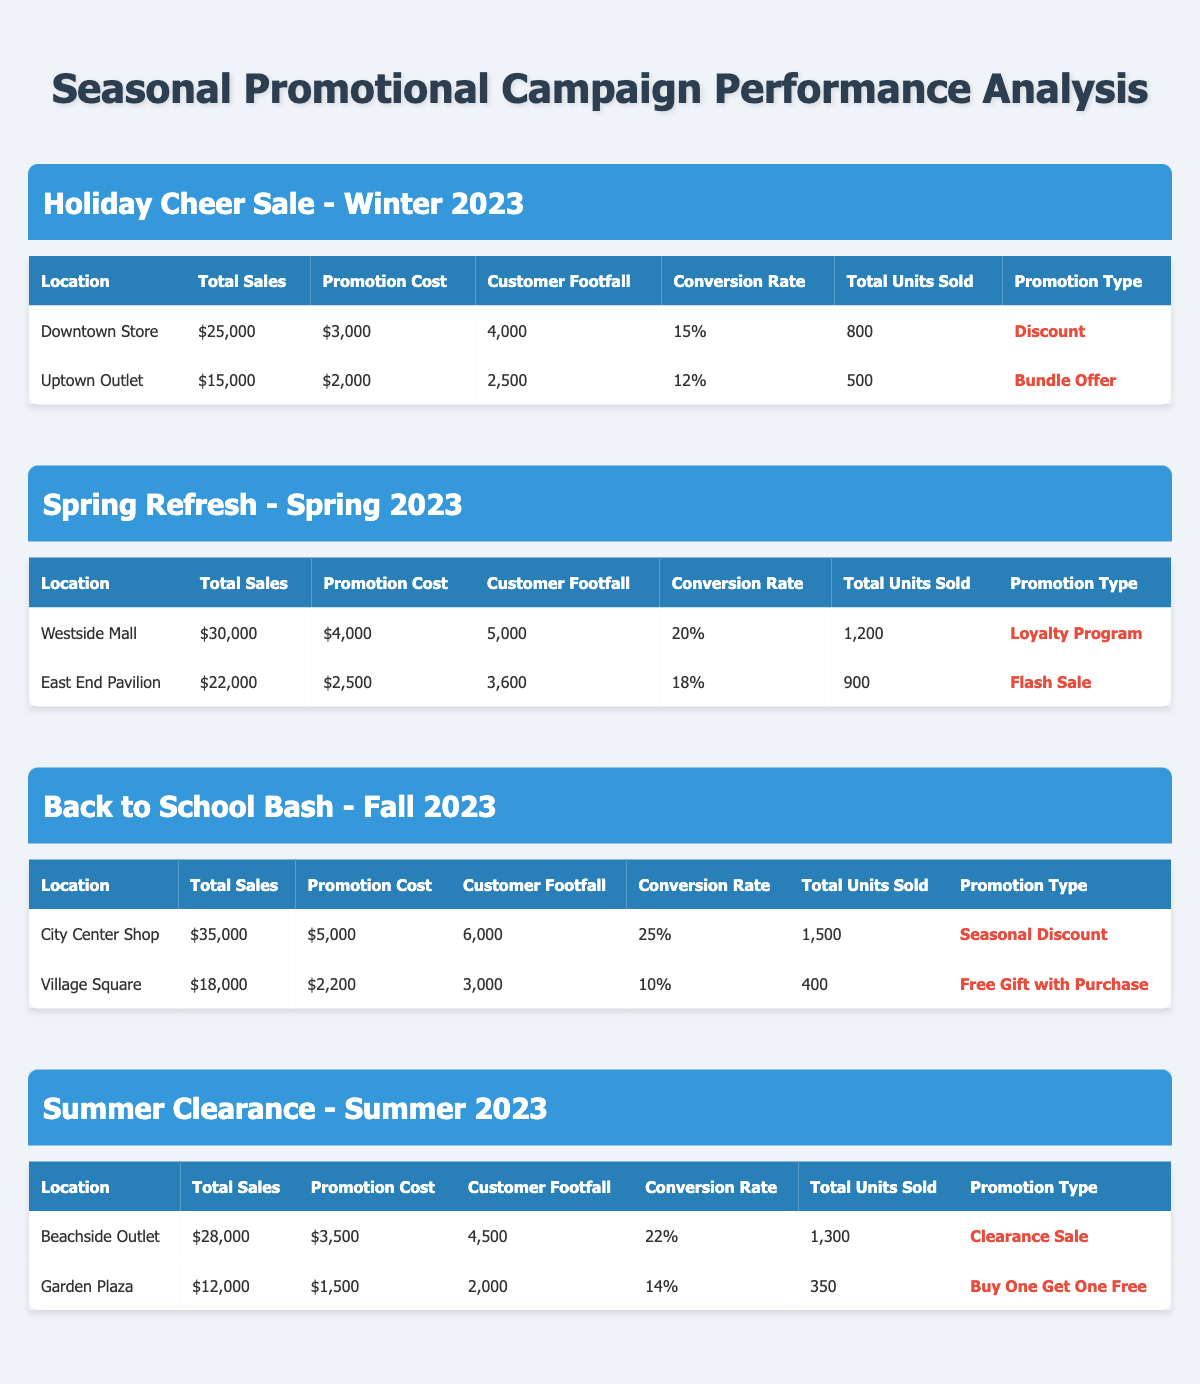What is the total sales for the Downtown Store during the Holiday Cheer Sale? The total sales for the Downtown Store is listed directly in the table under the "Total Sales" column for the respective campaign. It shows a value of $25,000.
Answer: $25,000 What promotion type was used for the East End Pavilion during the Spring Refresh campaign? The promotion type for East End Pavilion can be found in the corresponding row for that location under the "Promotion Type" column. It is stated as "Flash Sale."
Answer: Flash Sale Which retail location had the highest conversion rate, and what was that rate? Comparing the conversion rates listed for each location, City Center Shop has the highest rate at 25%. This can be confirmed by examining the "Conversion Rate" column of the data.
Answer: City Center Shop, 25% What was the average total sales for all locations in the Summer Clearance campaign? The total sales for the Summer Clearance campaign are $28,000 (Beachside Outlet) and $12,000 (Garden Plaza). Add these together to get $40,000. Then, divide by the number of locations (2) to find the average:  $40,000 / 2 = $20,000.
Answer: $20,000 Is it true that the Uptown Outlet had a higher total sales than the Village Square during the Back to School Bash? Looking at the values in the "Total Sales" column, Uptown Outlet has $15,000 and Village Square has $18,000. Since $15,000 is less than $18,000, the statement is false.
Answer: No What was the total promotion cost for all locations during the Spring Refresh campaign? The promotion costs for Westside Mall is $4,000 and East End Pavilion is $2,500. Adding these costs gives a total of $4,000 + $2,500 = $6,500.
Answer: $6,500 Which location had the lowest customer footfall during the Summer Clearance? Reviewing the "Customer Footfall" column, Garden Plaza has the lowest footfall at 2,000 compared to Beachside Outlet with 4,500. Hence, Garden Plaza is the location with the lowest footfall.
Answer: Garden Plaza What is the total units sold across all retail locations in the Holiday Cheer Sale? The total units sold for Downtown Store is 800 and for Uptown Outlet, it is 500. Summing these gives 800 + 500 = 1,300 units sold in total during this campaign.
Answer: 1,300 